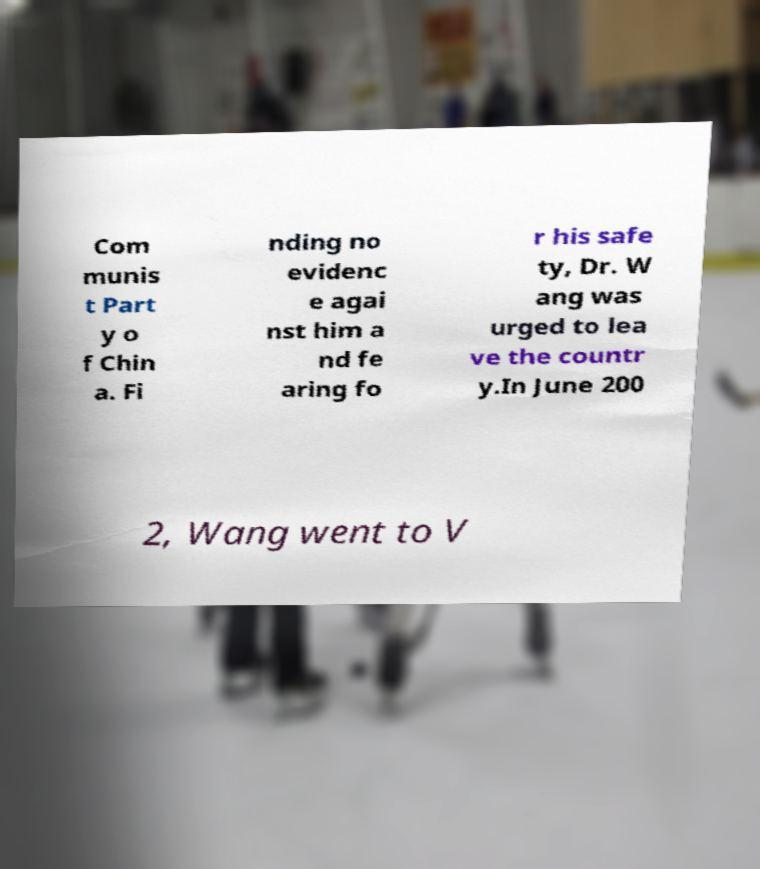For documentation purposes, I need the text within this image transcribed. Could you provide that? Com munis t Part y o f Chin a. Fi nding no evidenc e agai nst him a nd fe aring fo r his safe ty, Dr. W ang was urged to lea ve the countr y.In June 200 2, Wang went to V 